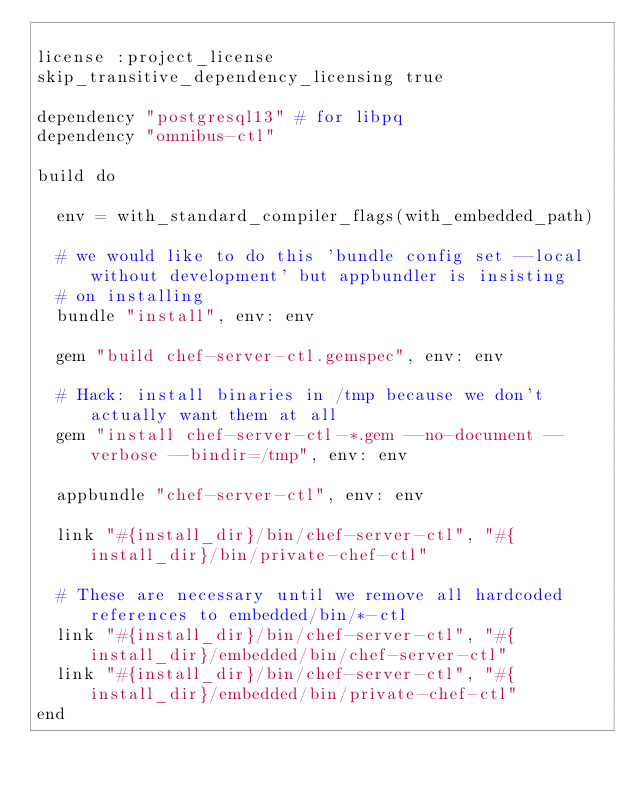<code> <loc_0><loc_0><loc_500><loc_500><_Ruby_>
license :project_license
skip_transitive_dependency_licensing true

dependency "postgresql13" # for libpq
dependency "omnibus-ctl"

build do

  env = with_standard_compiler_flags(with_embedded_path)

  # we would like to do this 'bundle config set --local without development' but appbundler is insisting
  # on installing
  bundle "install", env: env

  gem "build chef-server-ctl.gemspec", env: env

  # Hack: install binaries in /tmp because we don't actually want them at all
  gem "install chef-server-ctl-*.gem --no-document --verbose --bindir=/tmp", env: env

  appbundle "chef-server-ctl", env: env

  link "#{install_dir}/bin/chef-server-ctl", "#{install_dir}/bin/private-chef-ctl"

  # These are necessary until we remove all hardcoded references to embedded/bin/*-ctl
  link "#{install_dir}/bin/chef-server-ctl", "#{install_dir}/embedded/bin/chef-server-ctl"
  link "#{install_dir}/bin/chef-server-ctl", "#{install_dir}/embedded/bin/private-chef-ctl"
end
</code> 